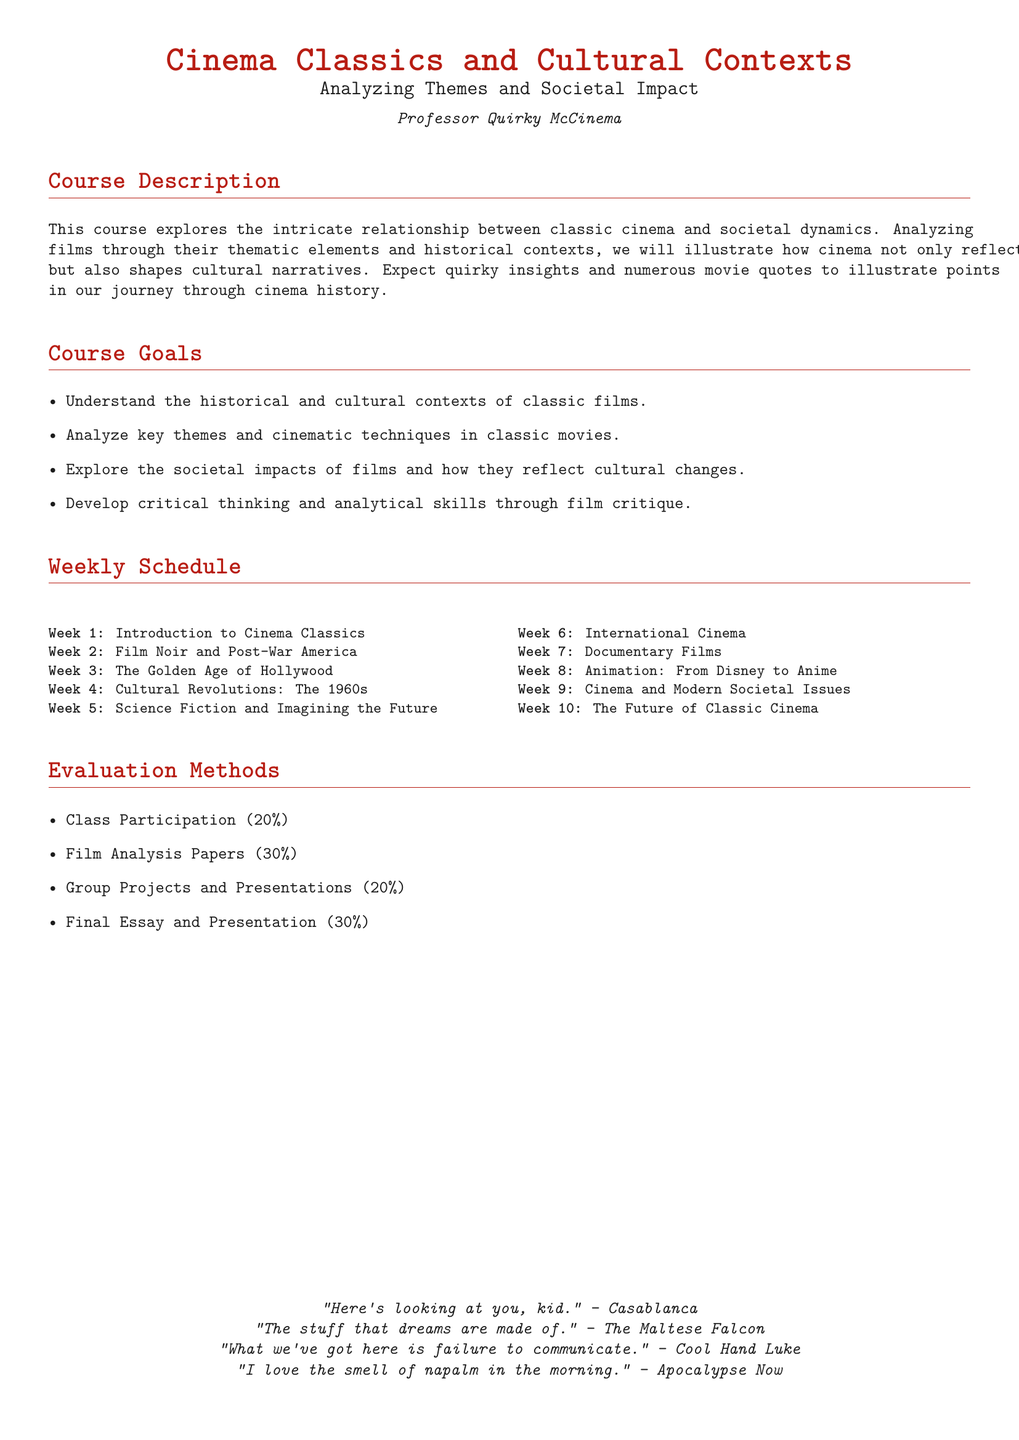What is the course title? The course title is prominently displayed at the top of the document, which is "Cinema Classics and Cultural Contexts."
Answer: Cinema Classics and Cultural Contexts Who is the instructor for the course? The instructor's name is mentioned in the title section of the document, identified as "Professor Quirky McCinema."
Answer: Professor Quirky McCinema What percentage of the evaluation is based on class participation? The syllabus specifies the evaluation methods, stating that class participation accounts for a specific percentage.
Answer: 20% What week covers the theme of Science Fiction? The weekly schedule outlines the topics for each week, including the specific week for Science Fiction films.
Answer: Week 5 How many weeks are included in the schedule? The document lists a total of ten distinct weeks in the schedule for the course.
Answer: 10 What type of films are studied in Week 2? The syllabus indicates the specific theme that will be studied in Week 2, which relates to a certain genre of cinema.
Answer: Film Noir What is the goal related to critical thinking? One of the course goals addresses the development of a specific skill set through film critique.
Answer: Develop critical thinking and analytical skills What quote is attributed to "Casablanca"? The document includes famous quotes from classic films, one of which is specified with the source "Casablanca."
Answer: Here's looking at you, kid 